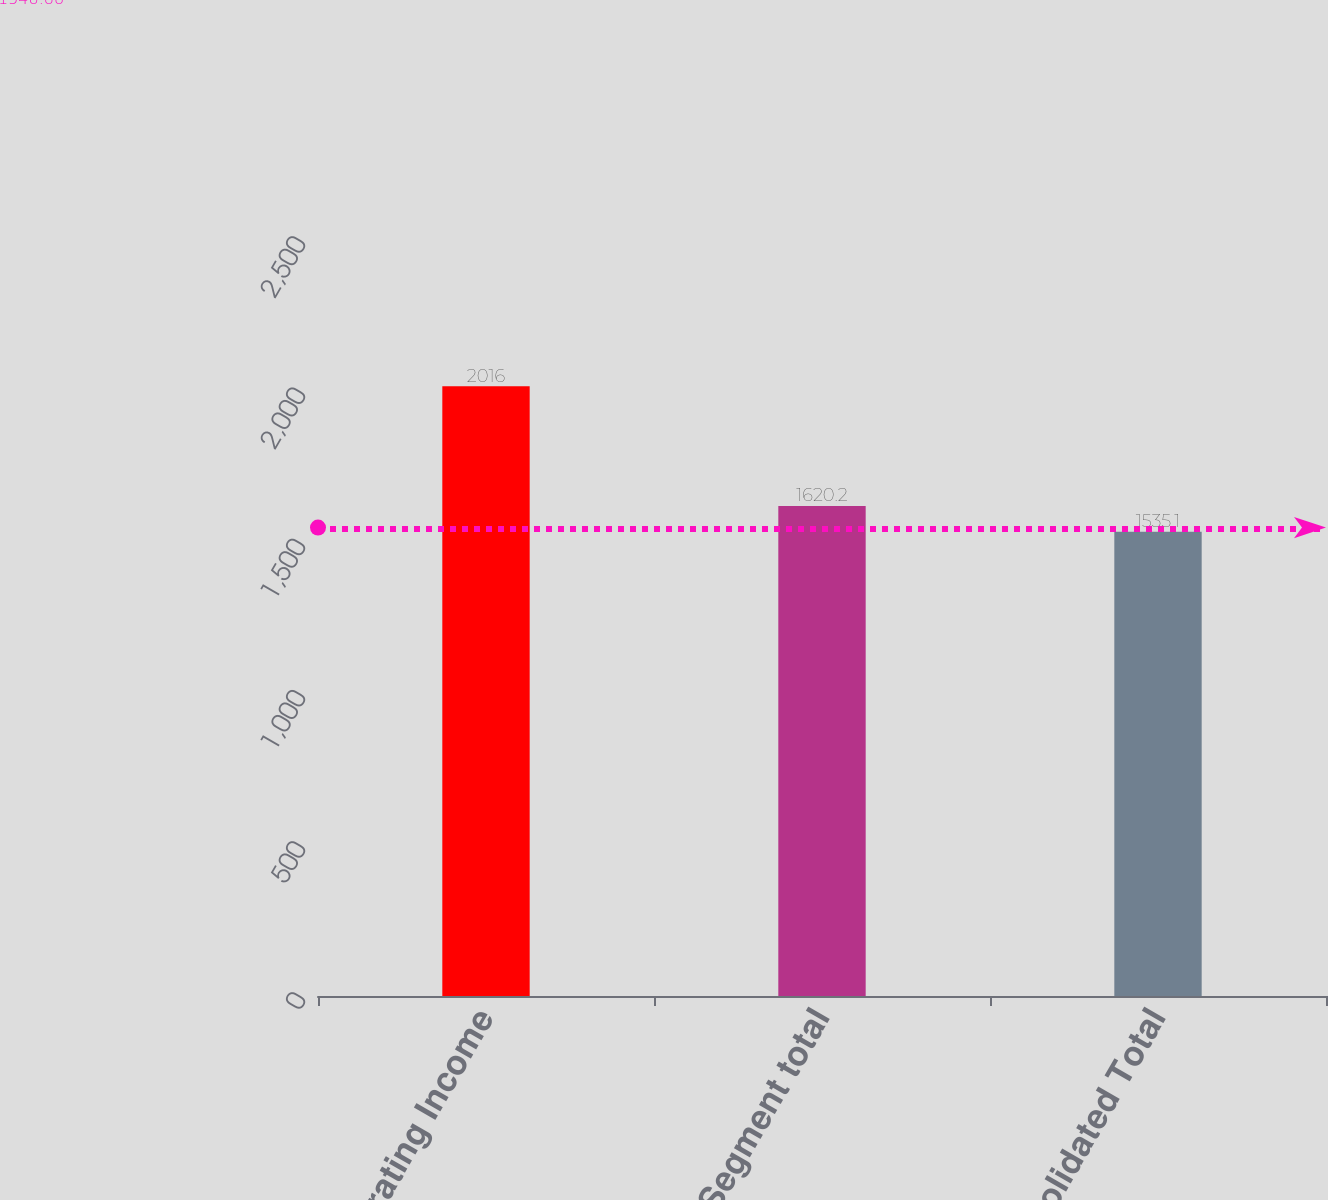Convert chart. <chart><loc_0><loc_0><loc_500><loc_500><bar_chart><fcel>Operating Income<fcel>Segment total<fcel>Consolidated Total<nl><fcel>2016<fcel>1620.2<fcel>1535.1<nl></chart> 